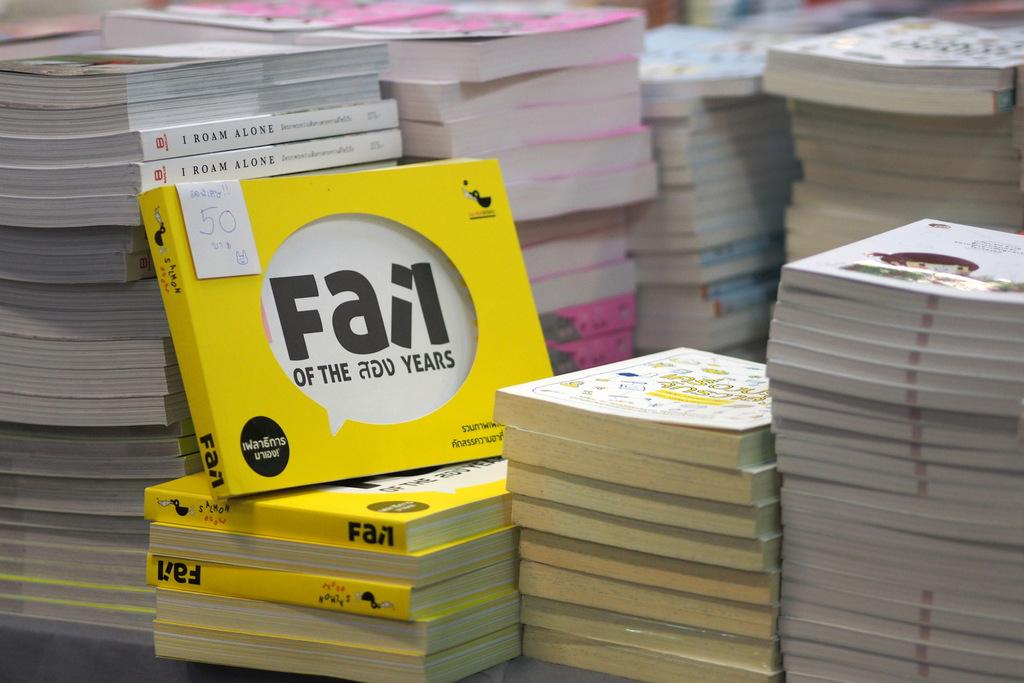<image>
Create a compact narrative representing the image presented. A stack of books with Fail of the 200 Years featured. 